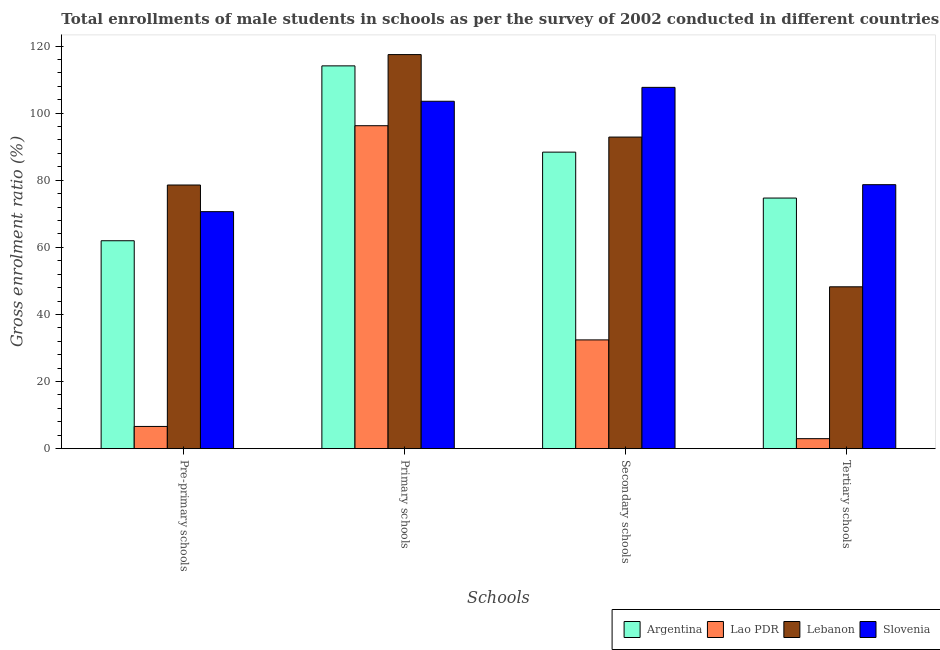How many different coloured bars are there?
Provide a short and direct response. 4. How many groups of bars are there?
Keep it short and to the point. 4. How many bars are there on the 1st tick from the left?
Give a very brief answer. 4. How many bars are there on the 3rd tick from the right?
Ensure brevity in your answer.  4. What is the label of the 2nd group of bars from the left?
Your answer should be very brief. Primary schools. What is the gross enrolment ratio(male) in primary schools in Argentina?
Make the answer very short. 114.08. Across all countries, what is the maximum gross enrolment ratio(male) in primary schools?
Make the answer very short. 117.45. Across all countries, what is the minimum gross enrolment ratio(male) in pre-primary schools?
Provide a succinct answer. 6.63. In which country was the gross enrolment ratio(male) in primary schools maximum?
Your response must be concise. Lebanon. In which country was the gross enrolment ratio(male) in tertiary schools minimum?
Provide a short and direct response. Lao PDR. What is the total gross enrolment ratio(male) in pre-primary schools in the graph?
Your answer should be compact. 217.81. What is the difference between the gross enrolment ratio(male) in tertiary schools in Slovenia and that in Argentina?
Provide a short and direct response. 3.99. What is the difference between the gross enrolment ratio(male) in secondary schools in Lao PDR and the gross enrolment ratio(male) in pre-primary schools in Argentina?
Your response must be concise. -29.55. What is the average gross enrolment ratio(male) in secondary schools per country?
Offer a terse response. 80.33. What is the difference between the gross enrolment ratio(male) in primary schools and gross enrolment ratio(male) in tertiary schools in Lebanon?
Keep it short and to the point. 69.2. In how many countries, is the gross enrolment ratio(male) in primary schools greater than 20 %?
Your answer should be very brief. 4. What is the ratio of the gross enrolment ratio(male) in tertiary schools in Slovenia to that in Lao PDR?
Offer a very short reply. 26.38. Is the gross enrolment ratio(male) in pre-primary schools in Lebanon less than that in Argentina?
Offer a terse response. No. What is the difference between the highest and the second highest gross enrolment ratio(male) in tertiary schools?
Provide a short and direct response. 3.99. What is the difference between the highest and the lowest gross enrolment ratio(male) in pre-primary schools?
Give a very brief answer. 71.95. What does the 3rd bar from the left in Tertiary schools represents?
Provide a short and direct response. Lebanon. What does the 2nd bar from the right in Pre-primary schools represents?
Make the answer very short. Lebanon. Is it the case that in every country, the sum of the gross enrolment ratio(male) in pre-primary schools and gross enrolment ratio(male) in primary schools is greater than the gross enrolment ratio(male) in secondary schools?
Keep it short and to the point. Yes. How many bars are there?
Offer a very short reply. 16. Are the values on the major ticks of Y-axis written in scientific E-notation?
Your answer should be very brief. No. Does the graph contain any zero values?
Provide a short and direct response. No. Does the graph contain grids?
Your answer should be very brief. No. Where does the legend appear in the graph?
Your response must be concise. Bottom right. How are the legend labels stacked?
Your answer should be very brief. Horizontal. What is the title of the graph?
Ensure brevity in your answer.  Total enrollments of male students in schools as per the survey of 2002 conducted in different countries. What is the label or title of the X-axis?
Your answer should be very brief. Schools. What is the label or title of the Y-axis?
Your answer should be very brief. Gross enrolment ratio (%). What is the Gross enrolment ratio (%) of Argentina in Pre-primary schools?
Ensure brevity in your answer.  61.97. What is the Gross enrolment ratio (%) in Lao PDR in Pre-primary schools?
Provide a short and direct response. 6.63. What is the Gross enrolment ratio (%) of Lebanon in Pre-primary schools?
Your response must be concise. 78.58. What is the Gross enrolment ratio (%) of Slovenia in Pre-primary schools?
Keep it short and to the point. 70.64. What is the Gross enrolment ratio (%) of Argentina in Primary schools?
Provide a succinct answer. 114.08. What is the Gross enrolment ratio (%) of Lao PDR in Primary schools?
Give a very brief answer. 96.25. What is the Gross enrolment ratio (%) of Lebanon in Primary schools?
Provide a short and direct response. 117.45. What is the Gross enrolment ratio (%) in Slovenia in Primary schools?
Provide a succinct answer. 103.53. What is the Gross enrolment ratio (%) in Argentina in Secondary schools?
Give a very brief answer. 88.38. What is the Gross enrolment ratio (%) of Lao PDR in Secondary schools?
Keep it short and to the point. 32.42. What is the Gross enrolment ratio (%) in Lebanon in Secondary schools?
Offer a terse response. 92.86. What is the Gross enrolment ratio (%) of Slovenia in Secondary schools?
Provide a short and direct response. 107.67. What is the Gross enrolment ratio (%) of Argentina in Tertiary schools?
Provide a short and direct response. 74.69. What is the Gross enrolment ratio (%) in Lao PDR in Tertiary schools?
Keep it short and to the point. 2.98. What is the Gross enrolment ratio (%) in Lebanon in Tertiary schools?
Give a very brief answer. 48.24. What is the Gross enrolment ratio (%) in Slovenia in Tertiary schools?
Keep it short and to the point. 78.68. Across all Schools, what is the maximum Gross enrolment ratio (%) of Argentina?
Provide a succinct answer. 114.08. Across all Schools, what is the maximum Gross enrolment ratio (%) of Lao PDR?
Your answer should be very brief. 96.25. Across all Schools, what is the maximum Gross enrolment ratio (%) of Lebanon?
Your answer should be very brief. 117.45. Across all Schools, what is the maximum Gross enrolment ratio (%) of Slovenia?
Give a very brief answer. 107.67. Across all Schools, what is the minimum Gross enrolment ratio (%) in Argentina?
Make the answer very short. 61.97. Across all Schools, what is the minimum Gross enrolment ratio (%) in Lao PDR?
Your answer should be compact. 2.98. Across all Schools, what is the minimum Gross enrolment ratio (%) of Lebanon?
Provide a succinct answer. 48.24. Across all Schools, what is the minimum Gross enrolment ratio (%) of Slovenia?
Provide a short and direct response. 70.64. What is the total Gross enrolment ratio (%) of Argentina in the graph?
Offer a terse response. 339.12. What is the total Gross enrolment ratio (%) in Lao PDR in the graph?
Offer a very short reply. 138.28. What is the total Gross enrolment ratio (%) in Lebanon in the graph?
Offer a very short reply. 337.13. What is the total Gross enrolment ratio (%) of Slovenia in the graph?
Keep it short and to the point. 360.52. What is the difference between the Gross enrolment ratio (%) in Argentina in Pre-primary schools and that in Primary schools?
Your response must be concise. -52.11. What is the difference between the Gross enrolment ratio (%) in Lao PDR in Pre-primary schools and that in Primary schools?
Offer a very short reply. -89.62. What is the difference between the Gross enrolment ratio (%) of Lebanon in Pre-primary schools and that in Primary schools?
Provide a succinct answer. -38.87. What is the difference between the Gross enrolment ratio (%) of Slovenia in Pre-primary schools and that in Primary schools?
Your answer should be very brief. -32.9. What is the difference between the Gross enrolment ratio (%) in Argentina in Pre-primary schools and that in Secondary schools?
Provide a succinct answer. -26.41. What is the difference between the Gross enrolment ratio (%) of Lao PDR in Pre-primary schools and that in Secondary schools?
Your answer should be compact. -25.79. What is the difference between the Gross enrolment ratio (%) of Lebanon in Pre-primary schools and that in Secondary schools?
Your response must be concise. -14.28. What is the difference between the Gross enrolment ratio (%) of Slovenia in Pre-primary schools and that in Secondary schools?
Offer a terse response. -37.03. What is the difference between the Gross enrolment ratio (%) of Argentina in Pre-primary schools and that in Tertiary schools?
Keep it short and to the point. -12.72. What is the difference between the Gross enrolment ratio (%) in Lao PDR in Pre-primary schools and that in Tertiary schools?
Provide a short and direct response. 3.65. What is the difference between the Gross enrolment ratio (%) of Lebanon in Pre-primary schools and that in Tertiary schools?
Give a very brief answer. 30.34. What is the difference between the Gross enrolment ratio (%) in Slovenia in Pre-primary schools and that in Tertiary schools?
Your answer should be very brief. -8.04. What is the difference between the Gross enrolment ratio (%) of Argentina in Primary schools and that in Secondary schools?
Your response must be concise. 25.71. What is the difference between the Gross enrolment ratio (%) of Lao PDR in Primary schools and that in Secondary schools?
Provide a short and direct response. 63.83. What is the difference between the Gross enrolment ratio (%) of Lebanon in Primary schools and that in Secondary schools?
Provide a short and direct response. 24.58. What is the difference between the Gross enrolment ratio (%) of Slovenia in Primary schools and that in Secondary schools?
Give a very brief answer. -4.14. What is the difference between the Gross enrolment ratio (%) in Argentina in Primary schools and that in Tertiary schools?
Offer a terse response. 39.39. What is the difference between the Gross enrolment ratio (%) in Lao PDR in Primary schools and that in Tertiary schools?
Provide a succinct answer. 93.27. What is the difference between the Gross enrolment ratio (%) in Lebanon in Primary schools and that in Tertiary schools?
Give a very brief answer. 69.2. What is the difference between the Gross enrolment ratio (%) of Slovenia in Primary schools and that in Tertiary schools?
Your response must be concise. 24.86. What is the difference between the Gross enrolment ratio (%) of Argentina in Secondary schools and that in Tertiary schools?
Your response must be concise. 13.68. What is the difference between the Gross enrolment ratio (%) of Lao PDR in Secondary schools and that in Tertiary schools?
Offer a very short reply. 29.44. What is the difference between the Gross enrolment ratio (%) of Lebanon in Secondary schools and that in Tertiary schools?
Offer a very short reply. 44.62. What is the difference between the Gross enrolment ratio (%) in Slovenia in Secondary schools and that in Tertiary schools?
Give a very brief answer. 29. What is the difference between the Gross enrolment ratio (%) in Argentina in Pre-primary schools and the Gross enrolment ratio (%) in Lao PDR in Primary schools?
Your answer should be very brief. -34.28. What is the difference between the Gross enrolment ratio (%) in Argentina in Pre-primary schools and the Gross enrolment ratio (%) in Lebanon in Primary schools?
Provide a short and direct response. -55.48. What is the difference between the Gross enrolment ratio (%) of Argentina in Pre-primary schools and the Gross enrolment ratio (%) of Slovenia in Primary schools?
Make the answer very short. -41.57. What is the difference between the Gross enrolment ratio (%) in Lao PDR in Pre-primary schools and the Gross enrolment ratio (%) in Lebanon in Primary schools?
Make the answer very short. -110.82. What is the difference between the Gross enrolment ratio (%) of Lao PDR in Pre-primary schools and the Gross enrolment ratio (%) of Slovenia in Primary schools?
Ensure brevity in your answer.  -96.91. What is the difference between the Gross enrolment ratio (%) of Lebanon in Pre-primary schools and the Gross enrolment ratio (%) of Slovenia in Primary schools?
Offer a very short reply. -24.95. What is the difference between the Gross enrolment ratio (%) in Argentina in Pre-primary schools and the Gross enrolment ratio (%) in Lao PDR in Secondary schools?
Give a very brief answer. 29.55. What is the difference between the Gross enrolment ratio (%) in Argentina in Pre-primary schools and the Gross enrolment ratio (%) in Lebanon in Secondary schools?
Ensure brevity in your answer.  -30.9. What is the difference between the Gross enrolment ratio (%) of Argentina in Pre-primary schools and the Gross enrolment ratio (%) of Slovenia in Secondary schools?
Provide a short and direct response. -45.7. What is the difference between the Gross enrolment ratio (%) in Lao PDR in Pre-primary schools and the Gross enrolment ratio (%) in Lebanon in Secondary schools?
Offer a terse response. -86.24. What is the difference between the Gross enrolment ratio (%) of Lao PDR in Pre-primary schools and the Gross enrolment ratio (%) of Slovenia in Secondary schools?
Ensure brevity in your answer.  -101.05. What is the difference between the Gross enrolment ratio (%) in Lebanon in Pre-primary schools and the Gross enrolment ratio (%) in Slovenia in Secondary schools?
Your response must be concise. -29.09. What is the difference between the Gross enrolment ratio (%) of Argentina in Pre-primary schools and the Gross enrolment ratio (%) of Lao PDR in Tertiary schools?
Give a very brief answer. 58.99. What is the difference between the Gross enrolment ratio (%) in Argentina in Pre-primary schools and the Gross enrolment ratio (%) in Lebanon in Tertiary schools?
Your answer should be compact. 13.73. What is the difference between the Gross enrolment ratio (%) of Argentina in Pre-primary schools and the Gross enrolment ratio (%) of Slovenia in Tertiary schools?
Offer a terse response. -16.71. What is the difference between the Gross enrolment ratio (%) in Lao PDR in Pre-primary schools and the Gross enrolment ratio (%) in Lebanon in Tertiary schools?
Offer a terse response. -41.61. What is the difference between the Gross enrolment ratio (%) in Lao PDR in Pre-primary schools and the Gross enrolment ratio (%) in Slovenia in Tertiary schools?
Ensure brevity in your answer.  -72.05. What is the difference between the Gross enrolment ratio (%) in Lebanon in Pre-primary schools and the Gross enrolment ratio (%) in Slovenia in Tertiary schools?
Keep it short and to the point. -0.1. What is the difference between the Gross enrolment ratio (%) of Argentina in Primary schools and the Gross enrolment ratio (%) of Lao PDR in Secondary schools?
Provide a succinct answer. 81.66. What is the difference between the Gross enrolment ratio (%) of Argentina in Primary schools and the Gross enrolment ratio (%) of Lebanon in Secondary schools?
Make the answer very short. 21.22. What is the difference between the Gross enrolment ratio (%) of Argentina in Primary schools and the Gross enrolment ratio (%) of Slovenia in Secondary schools?
Ensure brevity in your answer.  6.41. What is the difference between the Gross enrolment ratio (%) in Lao PDR in Primary schools and the Gross enrolment ratio (%) in Lebanon in Secondary schools?
Keep it short and to the point. 3.38. What is the difference between the Gross enrolment ratio (%) of Lao PDR in Primary schools and the Gross enrolment ratio (%) of Slovenia in Secondary schools?
Keep it short and to the point. -11.43. What is the difference between the Gross enrolment ratio (%) in Lebanon in Primary schools and the Gross enrolment ratio (%) in Slovenia in Secondary schools?
Provide a succinct answer. 9.77. What is the difference between the Gross enrolment ratio (%) in Argentina in Primary schools and the Gross enrolment ratio (%) in Lao PDR in Tertiary schools?
Provide a short and direct response. 111.1. What is the difference between the Gross enrolment ratio (%) of Argentina in Primary schools and the Gross enrolment ratio (%) of Lebanon in Tertiary schools?
Your answer should be very brief. 65.84. What is the difference between the Gross enrolment ratio (%) in Argentina in Primary schools and the Gross enrolment ratio (%) in Slovenia in Tertiary schools?
Offer a terse response. 35.41. What is the difference between the Gross enrolment ratio (%) of Lao PDR in Primary schools and the Gross enrolment ratio (%) of Lebanon in Tertiary schools?
Offer a terse response. 48.01. What is the difference between the Gross enrolment ratio (%) in Lao PDR in Primary schools and the Gross enrolment ratio (%) in Slovenia in Tertiary schools?
Offer a terse response. 17.57. What is the difference between the Gross enrolment ratio (%) in Lebanon in Primary schools and the Gross enrolment ratio (%) in Slovenia in Tertiary schools?
Make the answer very short. 38.77. What is the difference between the Gross enrolment ratio (%) in Argentina in Secondary schools and the Gross enrolment ratio (%) in Lao PDR in Tertiary schools?
Provide a short and direct response. 85.39. What is the difference between the Gross enrolment ratio (%) of Argentina in Secondary schools and the Gross enrolment ratio (%) of Lebanon in Tertiary schools?
Your response must be concise. 40.13. What is the difference between the Gross enrolment ratio (%) of Argentina in Secondary schools and the Gross enrolment ratio (%) of Slovenia in Tertiary schools?
Offer a very short reply. 9.7. What is the difference between the Gross enrolment ratio (%) in Lao PDR in Secondary schools and the Gross enrolment ratio (%) in Lebanon in Tertiary schools?
Provide a succinct answer. -15.82. What is the difference between the Gross enrolment ratio (%) of Lao PDR in Secondary schools and the Gross enrolment ratio (%) of Slovenia in Tertiary schools?
Offer a terse response. -46.26. What is the difference between the Gross enrolment ratio (%) in Lebanon in Secondary schools and the Gross enrolment ratio (%) in Slovenia in Tertiary schools?
Your answer should be very brief. 14.19. What is the average Gross enrolment ratio (%) of Argentina per Schools?
Keep it short and to the point. 84.78. What is the average Gross enrolment ratio (%) in Lao PDR per Schools?
Offer a very short reply. 34.57. What is the average Gross enrolment ratio (%) of Lebanon per Schools?
Ensure brevity in your answer.  84.28. What is the average Gross enrolment ratio (%) in Slovenia per Schools?
Your answer should be very brief. 90.13. What is the difference between the Gross enrolment ratio (%) in Argentina and Gross enrolment ratio (%) in Lao PDR in Pre-primary schools?
Ensure brevity in your answer.  55.34. What is the difference between the Gross enrolment ratio (%) in Argentina and Gross enrolment ratio (%) in Lebanon in Pre-primary schools?
Provide a short and direct response. -16.61. What is the difference between the Gross enrolment ratio (%) of Argentina and Gross enrolment ratio (%) of Slovenia in Pre-primary schools?
Give a very brief answer. -8.67. What is the difference between the Gross enrolment ratio (%) of Lao PDR and Gross enrolment ratio (%) of Lebanon in Pre-primary schools?
Provide a short and direct response. -71.95. What is the difference between the Gross enrolment ratio (%) of Lao PDR and Gross enrolment ratio (%) of Slovenia in Pre-primary schools?
Your response must be concise. -64.01. What is the difference between the Gross enrolment ratio (%) of Lebanon and Gross enrolment ratio (%) of Slovenia in Pre-primary schools?
Give a very brief answer. 7.94. What is the difference between the Gross enrolment ratio (%) of Argentina and Gross enrolment ratio (%) of Lao PDR in Primary schools?
Offer a terse response. 17.84. What is the difference between the Gross enrolment ratio (%) of Argentina and Gross enrolment ratio (%) of Lebanon in Primary schools?
Your answer should be very brief. -3.36. What is the difference between the Gross enrolment ratio (%) in Argentina and Gross enrolment ratio (%) in Slovenia in Primary schools?
Your answer should be very brief. 10.55. What is the difference between the Gross enrolment ratio (%) in Lao PDR and Gross enrolment ratio (%) in Lebanon in Primary schools?
Ensure brevity in your answer.  -21.2. What is the difference between the Gross enrolment ratio (%) of Lao PDR and Gross enrolment ratio (%) of Slovenia in Primary schools?
Your response must be concise. -7.29. What is the difference between the Gross enrolment ratio (%) in Lebanon and Gross enrolment ratio (%) in Slovenia in Primary schools?
Your answer should be compact. 13.91. What is the difference between the Gross enrolment ratio (%) of Argentina and Gross enrolment ratio (%) of Lao PDR in Secondary schools?
Provide a succinct answer. 55.96. What is the difference between the Gross enrolment ratio (%) of Argentina and Gross enrolment ratio (%) of Lebanon in Secondary schools?
Your response must be concise. -4.49. What is the difference between the Gross enrolment ratio (%) in Argentina and Gross enrolment ratio (%) in Slovenia in Secondary schools?
Offer a very short reply. -19.3. What is the difference between the Gross enrolment ratio (%) in Lao PDR and Gross enrolment ratio (%) in Lebanon in Secondary schools?
Your answer should be compact. -60.44. What is the difference between the Gross enrolment ratio (%) of Lao PDR and Gross enrolment ratio (%) of Slovenia in Secondary schools?
Offer a very short reply. -75.25. What is the difference between the Gross enrolment ratio (%) in Lebanon and Gross enrolment ratio (%) in Slovenia in Secondary schools?
Offer a very short reply. -14.81. What is the difference between the Gross enrolment ratio (%) of Argentina and Gross enrolment ratio (%) of Lao PDR in Tertiary schools?
Provide a short and direct response. 71.71. What is the difference between the Gross enrolment ratio (%) of Argentina and Gross enrolment ratio (%) of Lebanon in Tertiary schools?
Your response must be concise. 26.45. What is the difference between the Gross enrolment ratio (%) of Argentina and Gross enrolment ratio (%) of Slovenia in Tertiary schools?
Your answer should be compact. -3.99. What is the difference between the Gross enrolment ratio (%) of Lao PDR and Gross enrolment ratio (%) of Lebanon in Tertiary schools?
Offer a very short reply. -45.26. What is the difference between the Gross enrolment ratio (%) of Lao PDR and Gross enrolment ratio (%) of Slovenia in Tertiary schools?
Give a very brief answer. -75.69. What is the difference between the Gross enrolment ratio (%) in Lebanon and Gross enrolment ratio (%) in Slovenia in Tertiary schools?
Keep it short and to the point. -30.43. What is the ratio of the Gross enrolment ratio (%) in Argentina in Pre-primary schools to that in Primary schools?
Make the answer very short. 0.54. What is the ratio of the Gross enrolment ratio (%) in Lao PDR in Pre-primary schools to that in Primary schools?
Provide a short and direct response. 0.07. What is the ratio of the Gross enrolment ratio (%) of Lebanon in Pre-primary schools to that in Primary schools?
Offer a terse response. 0.67. What is the ratio of the Gross enrolment ratio (%) of Slovenia in Pre-primary schools to that in Primary schools?
Keep it short and to the point. 0.68. What is the ratio of the Gross enrolment ratio (%) of Argentina in Pre-primary schools to that in Secondary schools?
Give a very brief answer. 0.7. What is the ratio of the Gross enrolment ratio (%) of Lao PDR in Pre-primary schools to that in Secondary schools?
Give a very brief answer. 0.2. What is the ratio of the Gross enrolment ratio (%) in Lebanon in Pre-primary schools to that in Secondary schools?
Ensure brevity in your answer.  0.85. What is the ratio of the Gross enrolment ratio (%) of Slovenia in Pre-primary schools to that in Secondary schools?
Your answer should be very brief. 0.66. What is the ratio of the Gross enrolment ratio (%) of Argentina in Pre-primary schools to that in Tertiary schools?
Your answer should be very brief. 0.83. What is the ratio of the Gross enrolment ratio (%) in Lao PDR in Pre-primary schools to that in Tertiary schools?
Keep it short and to the point. 2.22. What is the ratio of the Gross enrolment ratio (%) of Lebanon in Pre-primary schools to that in Tertiary schools?
Your answer should be compact. 1.63. What is the ratio of the Gross enrolment ratio (%) in Slovenia in Pre-primary schools to that in Tertiary schools?
Your response must be concise. 0.9. What is the ratio of the Gross enrolment ratio (%) in Argentina in Primary schools to that in Secondary schools?
Give a very brief answer. 1.29. What is the ratio of the Gross enrolment ratio (%) of Lao PDR in Primary schools to that in Secondary schools?
Provide a succinct answer. 2.97. What is the ratio of the Gross enrolment ratio (%) of Lebanon in Primary schools to that in Secondary schools?
Keep it short and to the point. 1.26. What is the ratio of the Gross enrolment ratio (%) of Slovenia in Primary schools to that in Secondary schools?
Your response must be concise. 0.96. What is the ratio of the Gross enrolment ratio (%) of Argentina in Primary schools to that in Tertiary schools?
Provide a short and direct response. 1.53. What is the ratio of the Gross enrolment ratio (%) in Lao PDR in Primary schools to that in Tertiary schools?
Give a very brief answer. 32.27. What is the ratio of the Gross enrolment ratio (%) of Lebanon in Primary schools to that in Tertiary schools?
Your response must be concise. 2.43. What is the ratio of the Gross enrolment ratio (%) of Slovenia in Primary schools to that in Tertiary schools?
Make the answer very short. 1.32. What is the ratio of the Gross enrolment ratio (%) of Argentina in Secondary schools to that in Tertiary schools?
Provide a succinct answer. 1.18. What is the ratio of the Gross enrolment ratio (%) in Lao PDR in Secondary schools to that in Tertiary schools?
Give a very brief answer. 10.87. What is the ratio of the Gross enrolment ratio (%) in Lebanon in Secondary schools to that in Tertiary schools?
Make the answer very short. 1.93. What is the ratio of the Gross enrolment ratio (%) in Slovenia in Secondary schools to that in Tertiary schools?
Keep it short and to the point. 1.37. What is the difference between the highest and the second highest Gross enrolment ratio (%) of Argentina?
Your answer should be compact. 25.71. What is the difference between the highest and the second highest Gross enrolment ratio (%) of Lao PDR?
Make the answer very short. 63.83. What is the difference between the highest and the second highest Gross enrolment ratio (%) of Lebanon?
Provide a short and direct response. 24.58. What is the difference between the highest and the second highest Gross enrolment ratio (%) of Slovenia?
Your response must be concise. 4.14. What is the difference between the highest and the lowest Gross enrolment ratio (%) in Argentina?
Your answer should be compact. 52.11. What is the difference between the highest and the lowest Gross enrolment ratio (%) of Lao PDR?
Your response must be concise. 93.27. What is the difference between the highest and the lowest Gross enrolment ratio (%) in Lebanon?
Keep it short and to the point. 69.2. What is the difference between the highest and the lowest Gross enrolment ratio (%) of Slovenia?
Your response must be concise. 37.03. 